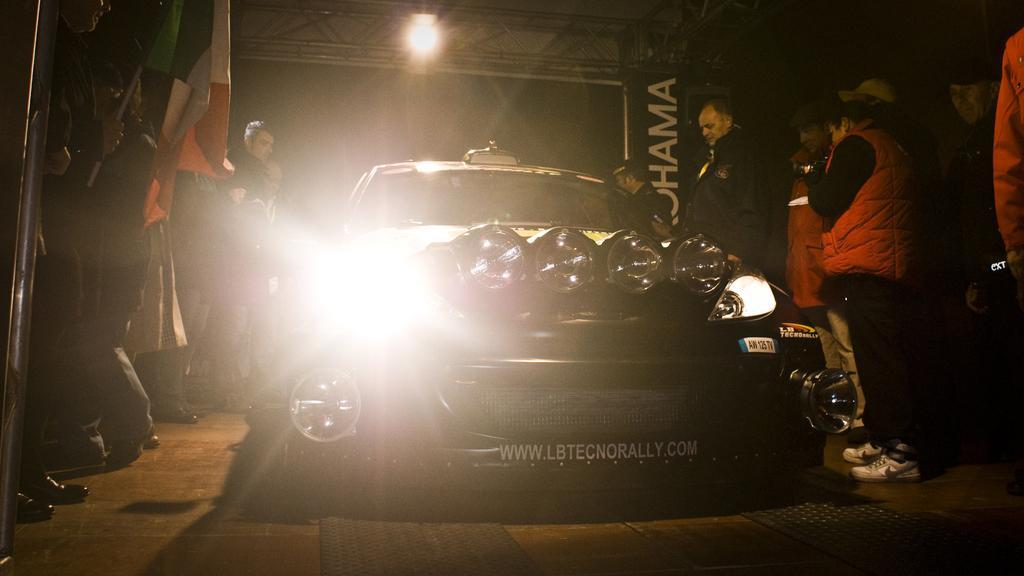How would you summarize this image in a sentence or two? In this picture we can see a car on the road and beside this car we can see some people standing, flags, banner, lights and in the background it is dark. 